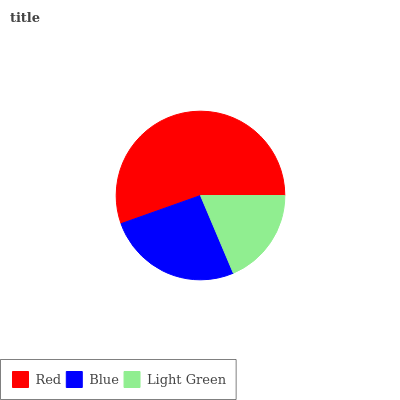Is Light Green the minimum?
Answer yes or no. Yes. Is Red the maximum?
Answer yes or no. Yes. Is Blue the minimum?
Answer yes or no. No. Is Blue the maximum?
Answer yes or no. No. Is Red greater than Blue?
Answer yes or no. Yes. Is Blue less than Red?
Answer yes or no. Yes. Is Blue greater than Red?
Answer yes or no. No. Is Red less than Blue?
Answer yes or no. No. Is Blue the high median?
Answer yes or no. Yes. Is Blue the low median?
Answer yes or no. Yes. Is Red the high median?
Answer yes or no. No. Is Light Green the low median?
Answer yes or no. No. 